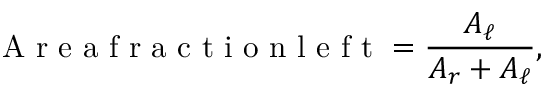Convert formula to latex. <formula><loc_0><loc_0><loc_500><loc_500>A r e a f r a c t i o n l e f t = \frac { A _ { \ell } } { A _ { r } + A _ { \ell } } ,</formula> 